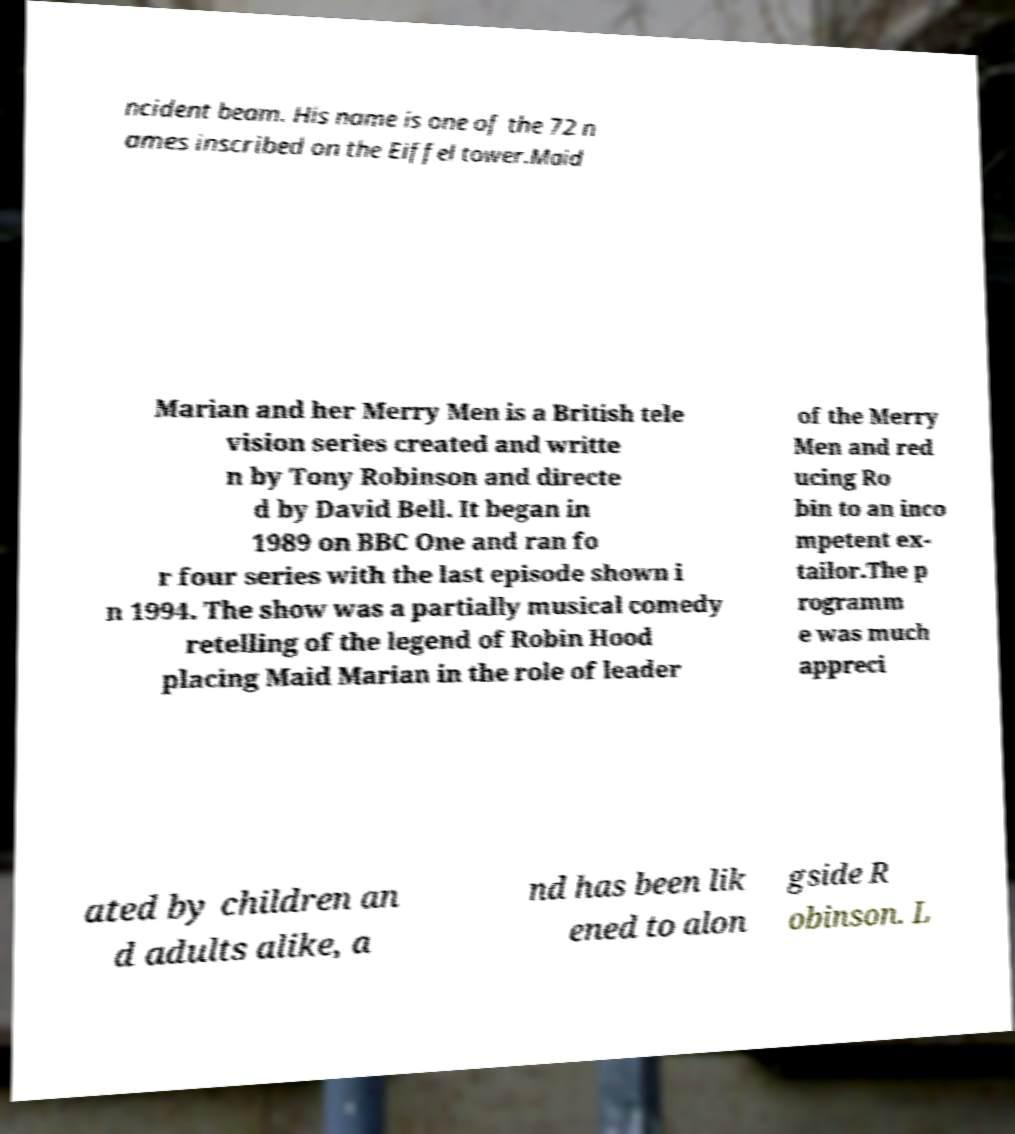Please read and relay the text visible in this image. What does it say? ncident beam. His name is one of the 72 n ames inscribed on the Eiffel tower.Maid Marian and her Merry Men is a British tele vision series created and writte n by Tony Robinson and directe d by David Bell. It began in 1989 on BBC One and ran fo r four series with the last episode shown i n 1994. The show was a partially musical comedy retelling of the legend of Robin Hood placing Maid Marian in the role of leader of the Merry Men and red ucing Ro bin to an inco mpetent ex- tailor.The p rogramm e was much appreci ated by children an d adults alike, a nd has been lik ened to alon gside R obinson. L 